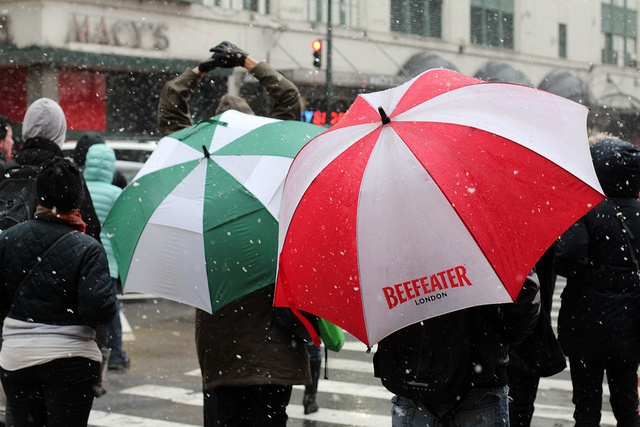Describe the objects in this image and their specific colors. I can see umbrella in gray, lavender, darkgray, and brown tones, umbrella in gray, lavender, darkgray, turquoise, and teal tones, people in gray, black, darkgray, and purple tones, people in gray, black, darkgray, and purple tones, and people in gray, black, darkgray, and maroon tones in this image. 